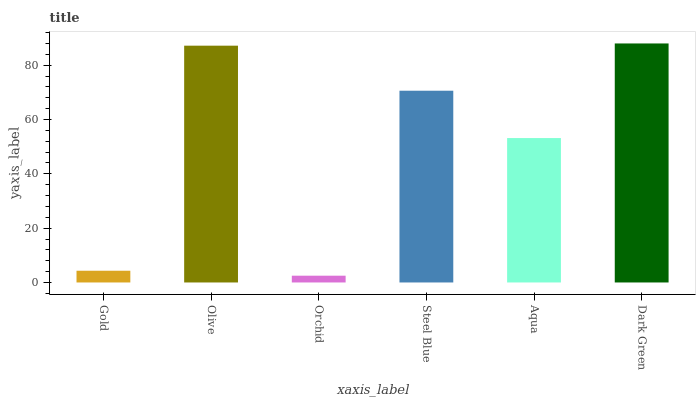Is Orchid the minimum?
Answer yes or no. Yes. Is Dark Green the maximum?
Answer yes or no. Yes. Is Olive the minimum?
Answer yes or no. No. Is Olive the maximum?
Answer yes or no. No. Is Olive greater than Gold?
Answer yes or no. Yes. Is Gold less than Olive?
Answer yes or no. Yes. Is Gold greater than Olive?
Answer yes or no. No. Is Olive less than Gold?
Answer yes or no. No. Is Steel Blue the high median?
Answer yes or no. Yes. Is Aqua the low median?
Answer yes or no. Yes. Is Aqua the high median?
Answer yes or no. No. Is Steel Blue the low median?
Answer yes or no. No. 